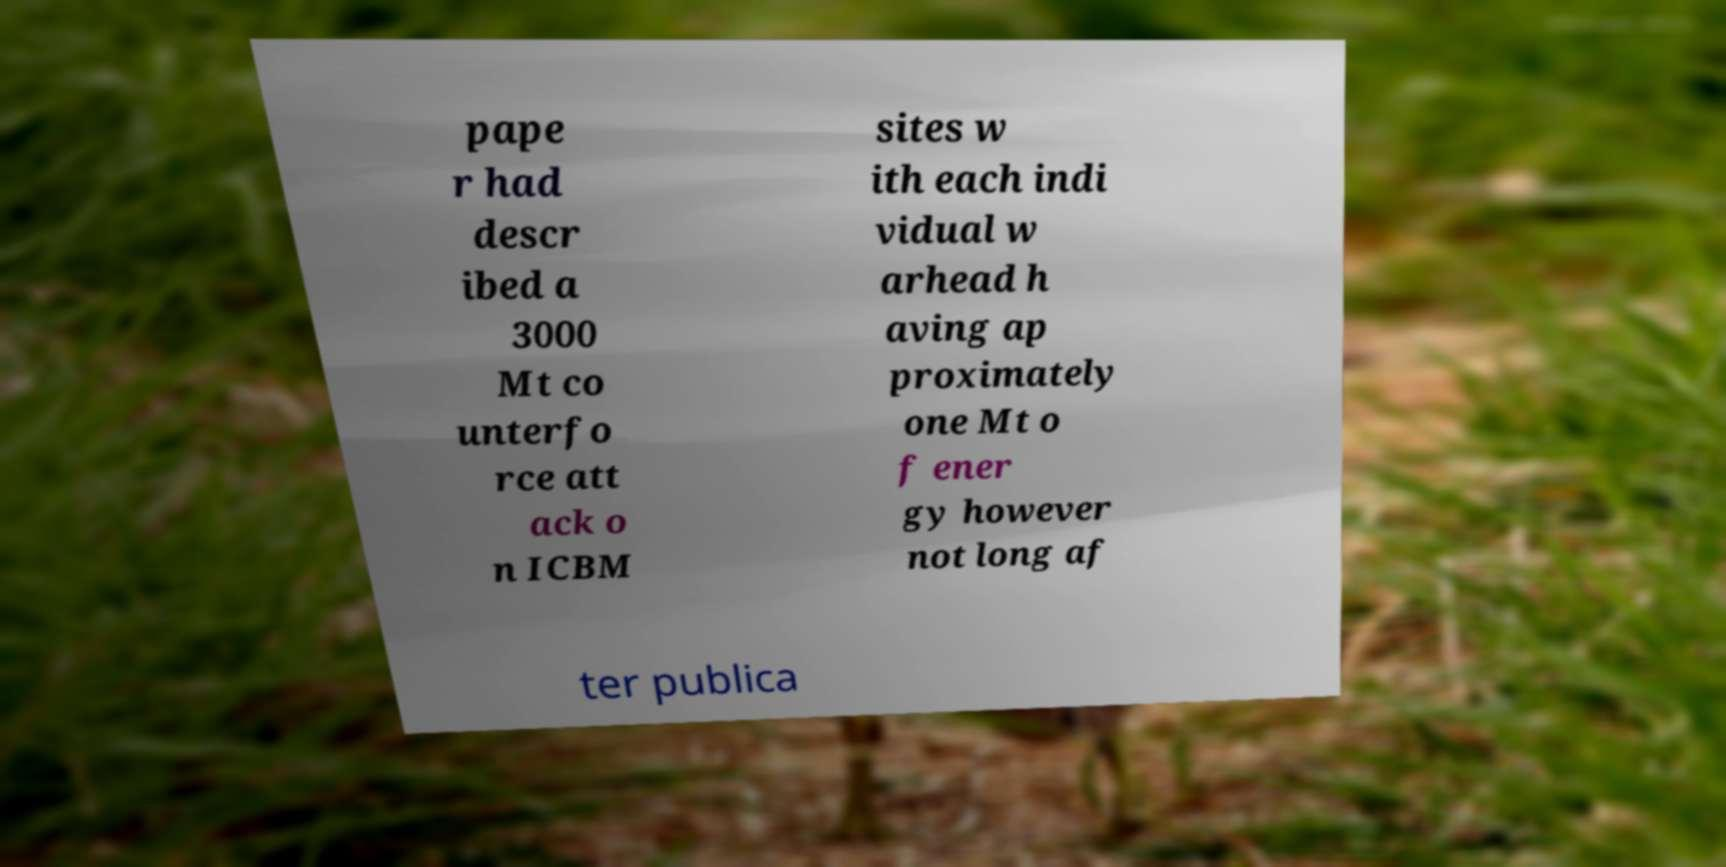Can you accurately transcribe the text from the provided image for me? pape r had descr ibed a 3000 Mt co unterfo rce att ack o n ICBM sites w ith each indi vidual w arhead h aving ap proximately one Mt o f ener gy however not long af ter publica 